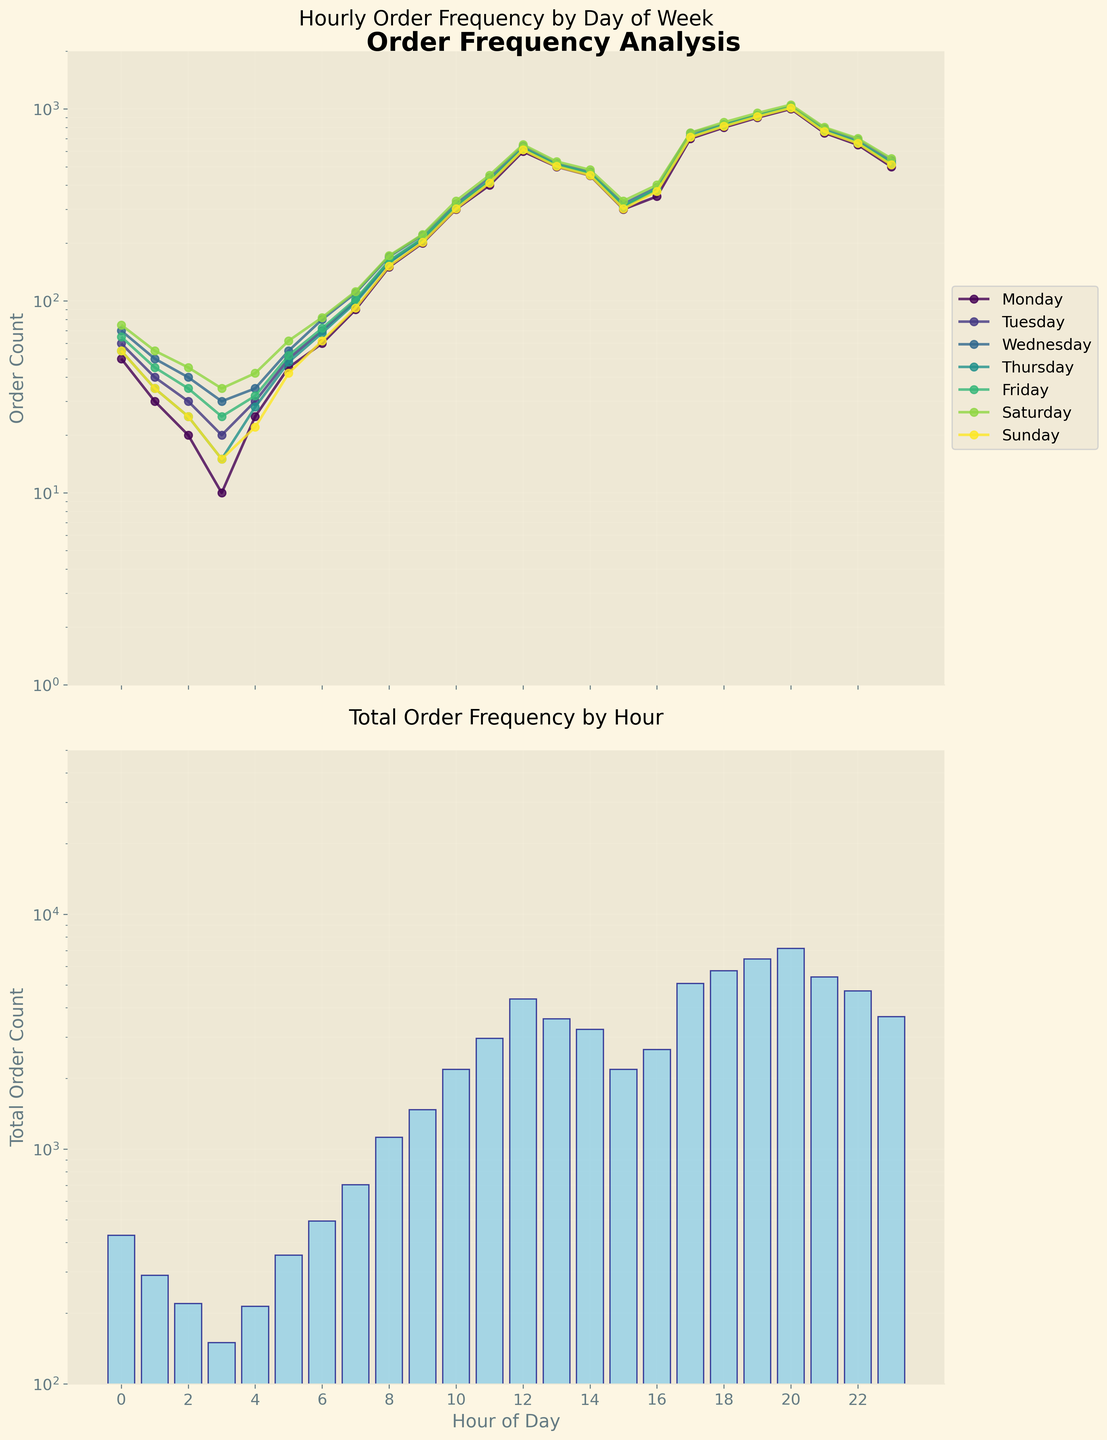What is the title of the first subplot? The first subplot is focused on the hourly order frequency by day of the week. The title is placed at the top of the first subplot.
Answer: Hourly Order Frequency by Day of Week Which weekday has the highest peak order count in the first subplot? The line plot for Monday peaks at the highest point compared to other days, especially around the 20th hour.
Answer: Monday At what hour do Sunday orders start to significantly increase, according to the first subplot? The Sunday line plot shows a visible increase in the slope after the 16th hour, indicating a significant rise in orders.
Answer: 16th hour What is the total range of the y-axis in the second subplot? The y-axis of the second subplot uses a logarithmic scale, ranging from 100 to 50,000, as indicated by the axis labels.
Answer: 100 to 50,000 How does the total order count differ from 12 PM to 6 PM in the second subplot? By observing the bar heights between 12 PM and 6 PM, there's a noticeable decline with the peak around 12 PM and a dip by 6 PM. The difference is observed in the bar heights.
Answer: Declines from 12 PM to 6 PM What is the order count at the peak time on Saturdays? The Saturday line reaches its peak on the first subplot around the 20th hour, and the y-axis reads close to 1050.
Answer: 1050 Between which hours does the largest increase in total orders occur? By comparing the bars in the second subplot, the largest increase appears between the 16th and 20th hours, where the bar height more than doubles.
Answer: 16th to 20th hour How do orders vary throughout the week shown in the first subplot? The lines for each day show that orders typically increase from the early morning hours, peak in the evening before declining towards midnight. This trend appears consistent across all days.
Answer: Increase in the morning, peak in the evening, decline at night Which information is displayed using a logarithmic scale in these subplots? Both subplots use a logarithmic scale on the y-axis to better visualize the wide range of order counts, from low early morning values to high evening peaks.
Answer: Order counts on the y-axis 